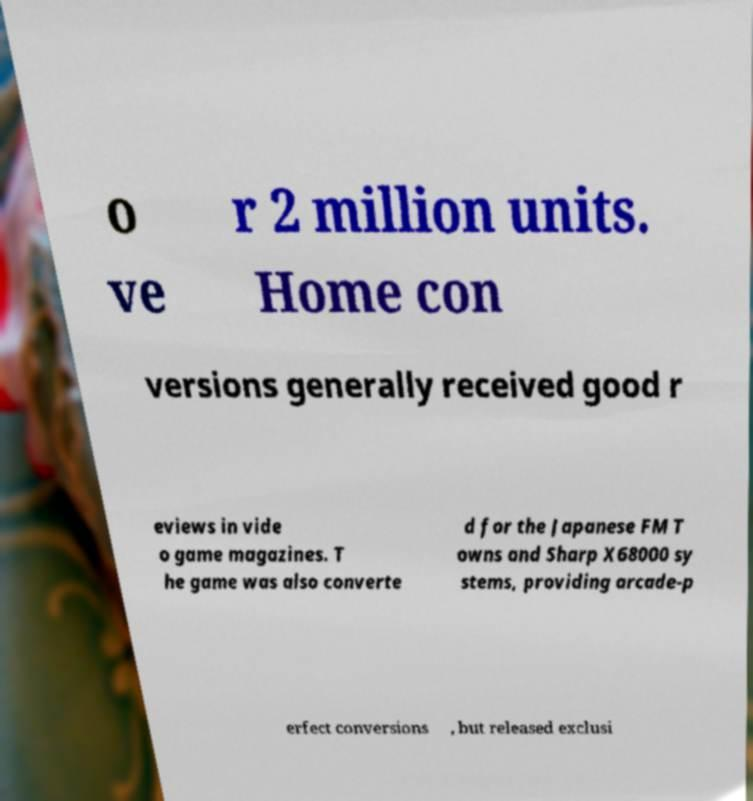Can you read and provide the text displayed in the image?This photo seems to have some interesting text. Can you extract and type it out for me? o ve r 2 million units. Home con versions generally received good r eviews in vide o game magazines. T he game was also converte d for the Japanese FM T owns and Sharp X68000 sy stems, providing arcade-p erfect conversions , but released exclusi 